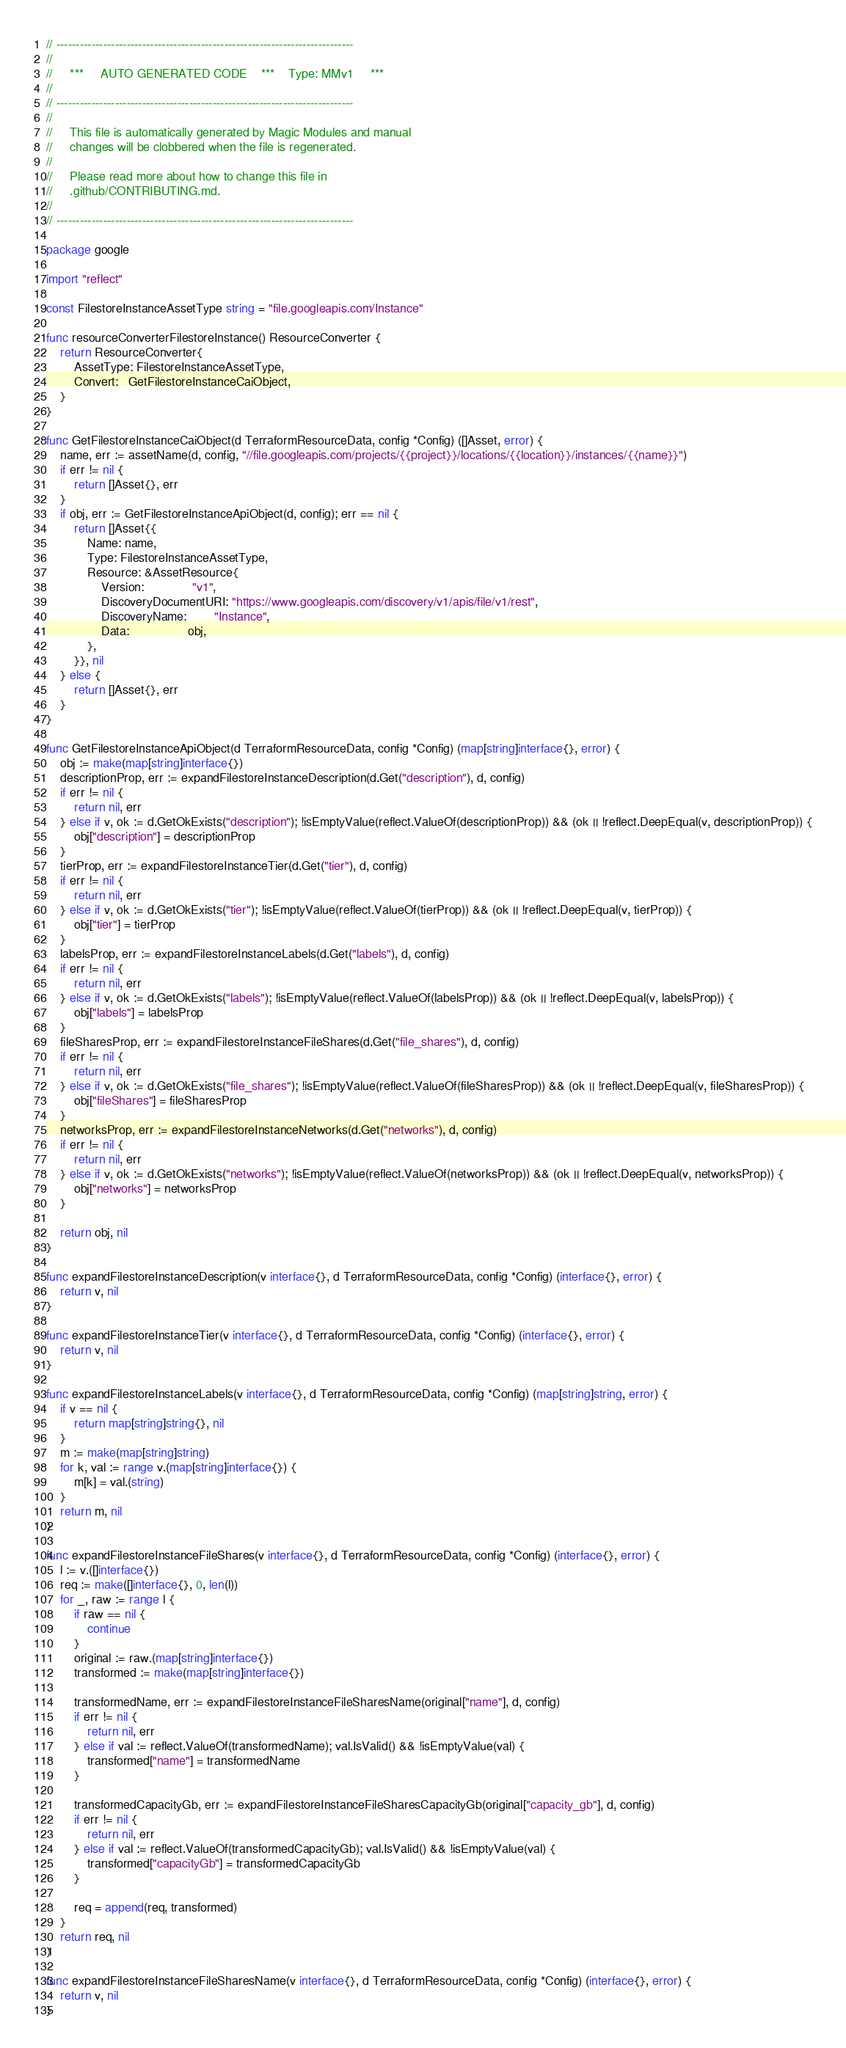<code> <loc_0><loc_0><loc_500><loc_500><_Go_>// ----------------------------------------------------------------------------
//
//     ***     AUTO GENERATED CODE    ***    Type: MMv1     ***
//
// ----------------------------------------------------------------------------
//
//     This file is automatically generated by Magic Modules and manual
//     changes will be clobbered when the file is regenerated.
//
//     Please read more about how to change this file in
//     .github/CONTRIBUTING.md.
//
// ----------------------------------------------------------------------------

package google

import "reflect"

const FilestoreInstanceAssetType string = "file.googleapis.com/Instance"

func resourceConverterFilestoreInstance() ResourceConverter {
	return ResourceConverter{
		AssetType: FilestoreInstanceAssetType,
		Convert:   GetFilestoreInstanceCaiObject,
	}
}

func GetFilestoreInstanceCaiObject(d TerraformResourceData, config *Config) ([]Asset, error) {
	name, err := assetName(d, config, "//file.googleapis.com/projects/{{project}}/locations/{{location}}/instances/{{name}}")
	if err != nil {
		return []Asset{}, err
	}
	if obj, err := GetFilestoreInstanceApiObject(d, config); err == nil {
		return []Asset{{
			Name: name,
			Type: FilestoreInstanceAssetType,
			Resource: &AssetResource{
				Version:              "v1",
				DiscoveryDocumentURI: "https://www.googleapis.com/discovery/v1/apis/file/v1/rest",
				DiscoveryName:        "Instance",
				Data:                 obj,
			},
		}}, nil
	} else {
		return []Asset{}, err
	}
}

func GetFilestoreInstanceApiObject(d TerraformResourceData, config *Config) (map[string]interface{}, error) {
	obj := make(map[string]interface{})
	descriptionProp, err := expandFilestoreInstanceDescription(d.Get("description"), d, config)
	if err != nil {
		return nil, err
	} else if v, ok := d.GetOkExists("description"); !isEmptyValue(reflect.ValueOf(descriptionProp)) && (ok || !reflect.DeepEqual(v, descriptionProp)) {
		obj["description"] = descriptionProp
	}
	tierProp, err := expandFilestoreInstanceTier(d.Get("tier"), d, config)
	if err != nil {
		return nil, err
	} else if v, ok := d.GetOkExists("tier"); !isEmptyValue(reflect.ValueOf(tierProp)) && (ok || !reflect.DeepEqual(v, tierProp)) {
		obj["tier"] = tierProp
	}
	labelsProp, err := expandFilestoreInstanceLabels(d.Get("labels"), d, config)
	if err != nil {
		return nil, err
	} else if v, ok := d.GetOkExists("labels"); !isEmptyValue(reflect.ValueOf(labelsProp)) && (ok || !reflect.DeepEqual(v, labelsProp)) {
		obj["labels"] = labelsProp
	}
	fileSharesProp, err := expandFilestoreInstanceFileShares(d.Get("file_shares"), d, config)
	if err != nil {
		return nil, err
	} else if v, ok := d.GetOkExists("file_shares"); !isEmptyValue(reflect.ValueOf(fileSharesProp)) && (ok || !reflect.DeepEqual(v, fileSharesProp)) {
		obj["fileShares"] = fileSharesProp
	}
	networksProp, err := expandFilestoreInstanceNetworks(d.Get("networks"), d, config)
	if err != nil {
		return nil, err
	} else if v, ok := d.GetOkExists("networks"); !isEmptyValue(reflect.ValueOf(networksProp)) && (ok || !reflect.DeepEqual(v, networksProp)) {
		obj["networks"] = networksProp
	}

	return obj, nil
}

func expandFilestoreInstanceDescription(v interface{}, d TerraformResourceData, config *Config) (interface{}, error) {
	return v, nil
}

func expandFilestoreInstanceTier(v interface{}, d TerraformResourceData, config *Config) (interface{}, error) {
	return v, nil
}

func expandFilestoreInstanceLabels(v interface{}, d TerraformResourceData, config *Config) (map[string]string, error) {
	if v == nil {
		return map[string]string{}, nil
	}
	m := make(map[string]string)
	for k, val := range v.(map[string]interface{}) {
		m[k] = val.(string)
	}
	return m, nil
}

func expandFilestoreInstanceFileShares(v interface{}, d TerraformResourceData, config *Config) (interface{}, error) {
	l := v.([]interface{})
	req := make([]interface{}, 0, len(l))
	for _, raw := range l {
		if raw == nil {
			continue
		}
		original := raw.(map[string]interface{})
		transformed := make(map[string]interface{})

		transformedName, err := expandFilestoreInstanceFileSharesName(original["name"], d, config)
		if err != nil {
			return nil, err
		} else if val := reflect.ValueOf(transformedName); val.IsValid() && !isEmptyValue(val) {
			transformed["name"] = transformedName
		}

		transformedCapacityGb, err := expandFilestoreInstanceFileSharesCapacityGb(original["capacity_gb"], d, config)
		if err != nil {
			return nil, err
		} else if val := reflect.ValueOf(transformedCapacityGb); val.IsValid() && !isEmptyValue(val) {
			transformed["capacityGb"] = transformedCapacityGb
		}

		req = append(req, transformed)
	}
	return req, nil
}

func expandFilestoreInstanceFileSharesName(v interface{}, d TerraformResourceData, config *Config) (interface{}, error) {
	return v, nil
}
</code> 